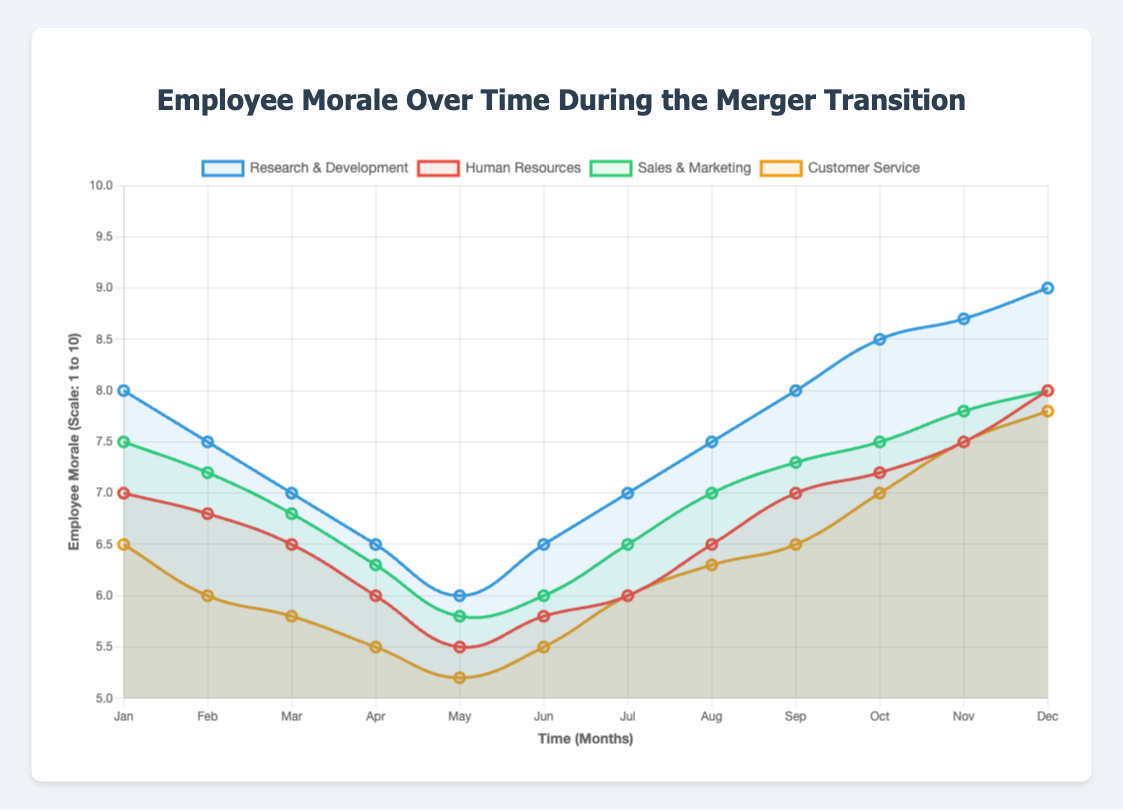What is the overall trend in employee morale for the Research & Development group from January to December? Observing the data for the Research & Development group, morale starts high at 8 in January, dips to 6 in May, then recovers, reaching 9 in December. This indicates an initial drop followed by a steady rise throughout the year.
Answer: Initial dip, then steady rise How does the morale in Human Resources in March compare to that in Sales & Marketing in March? In March, Human Resources’ morale is 6.5, while Sales & Marketing's morale is 6.8. Comparing these values shows that Sales & Marketing's morale is slightly higher.
Answer: Sales & Marketing is higher Which employee group shows the greatest increase in morale from May to December? Calculating the increase for each group: 
- Research & Development: 9 - 6 = 3
- Human Resources: 8 - 5.5 = 2.5
- Sales & Marketing: 8 - 5.8 = 2.2
- Customer Service: 7.8 - 5.2 = 2.6 
The greatest increase is in Research & Development.
Answer: Research & Development Between which two consecutive months does the Sales & Marketing group's morale see the steepest increase? Observing the differences month by month:
- Feb to Mar: 6.8 - 7.2 = -0.4
- Mar to Apr: 6.3 - 6.8 = -0.5
- Apr to May: 5.8 - 6.3 = -0.5
- May to Jun: 6 - 5.8 = 0.2
- Jun to Jul: 6.5 - 6 = 0.5
- Jul to Aug: 7 - 6.5 = 0.5
The steepest increase is seen from Jul to Aug.
Answer: July to August Which group had the lowest average morale over the year? Calculating the averages:
- Research & Development: (sum of all monthly morales) / 12 = 7.33
- Human Resources: (sum of all monthly morales) / 12 = 6.4
- Sales & Marketing: (sum of all monthly morales) / 12 = 6.7
- Customer Service: (sum of all monthly morales) / 12 = 6.17
Customer Service has the lowest average.
Answer: Customer Service From which month onwards did the Research & Development group show a continuous increase in morale until the end of the year? Starting from May, the Research & Development group's morale increases each month: May (6), Jun (6.5), Jul (7), Aug (7.5), Sep (8), Oct (8.5), Nov (8.7), Dec (9). Therefore, the continuous increase starts from May.
Answer: May 